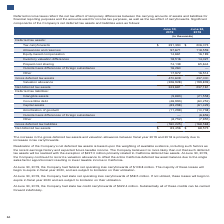According to Lam Research Corporation's financial document, What was the amount of federal net operating loss carryforwards at June 30, 2019? According to the financial document, $109.8 million. The relevant text states: "ny had federal net operating loss carryforwards of $109.8 million. The majority of these losses will begin to expire in fiscal year 2020, and are subject to limitati..." Also, What was the amount of state net operating loss carryforwards at June 30, 2019? According to the financial document, $58.5 million. The relevant text states: "pany had state net operating loss carryforwards of $58.5 million. If not utilized, these losses will begin to expire in fiscal year 2020 and are subject to limitati..." Also, What was the amount of state tax credit carryforwards at June 30, 2019? According to the financial document, $322.4 million. The relevant text states: "the Company had state tax credit carryforwards of $322.4 million. Substantially all of these credits can be carried forward indefinitely...." Also, can you calculate: What is the percentage change in the tax carry forwards from 2018 to 2019? To answer this question, I need to perform calculations using the financial data. The calculation is: (231,390-206,073)/206,073, which equals 12.29 (percentage). This is based on the information: "Tax carryforwards $ 231,390 $ 206,073 Tax carryforwards $ 231,390 $ 206,073..." The key data points involved are: 206,073, 231,390. Also, can you calculate: What is the percentage change in the gross deferred tax assets from 2018 to 2019? To answer this question, I need to perform calculations using the financial data. The calculation is: (470,609-437,000)/437,000, which equals 7.69 (percentage). This is based on the information: "Gross deferred tax assets 470,609 437,000 Gross deferred tax assets 470,609 437,000..." The key data points involved are: 437,000, 470,609. Additionally, In which year is the net deferred tax assets higher? According to the financial document, 2019. The relevant text states: "June 30, 2019 June 24, 2018..." 